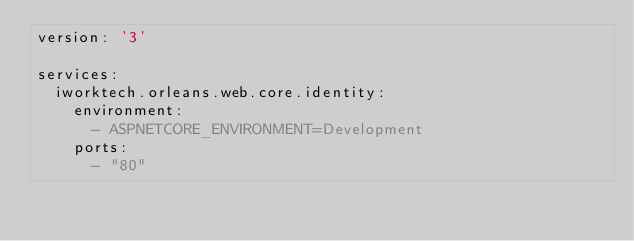<code> <loc_0><loc_0><loc_500><loc_500><_YAML_>version: '3'

services:
  iworktech.orleans.web.core.identity:
    environment:
      - ASPNETCORE_ENVIRONMENT=Development
    ports:
      - "80"
</code> 